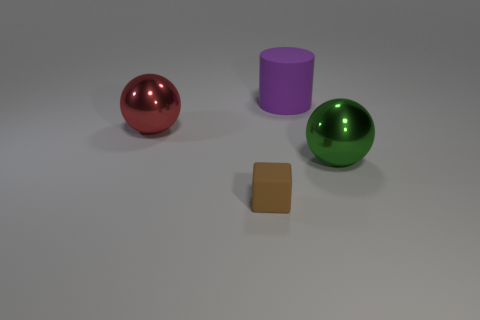Add 3 green spheres. How many objects exist? 7 Subtract all blocks. How many objects are left? 3 Subtract 0 purple balls. How many objects are left? 4 Subtract all spheres. Subtract all green metal cubes. How many objects are left? 2 Add 4 big green metal things. How many big green metal things are left? 5 Add 2 tiny matte things. How many tiny matte things exist? 3 